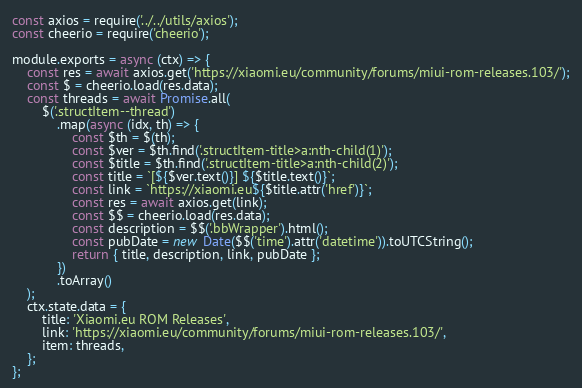<code> <loc_0><loc_0><loc_500><loc_500><_JavaScript_>const axios = require('../../utils/axios');
const cheerio = require('cheerio');

module.exports = async (ctx) => {
    const res = await axios.get('https://xiaomi.eu/community/forums/miui-rom-releases.103/');
    const $ = cheerio.load(res.data);
    const threads = await Promise.all(
        $('.structItem--thread')
            .map(async (idx, th) => {
                const $th = $(th);
                const $ver = $th.find('.structItem-title>a:nth-child(1)');
                const $title = $th.find('.structItem-title>a:nth-child(2)');
                const title = `[${$ver.text()}] ${$title.text()}`;
                const link = `https://xiaomi.eu${$title.attr('href')}`;
                const res = await axios.get(link);
                const $$ = cheerio.load(res.data);
                const description = $$('.bbWrapper').html();
                const pubDate = new Date($$('time').attr('datetime')).toUTCString();
                return { title, description, link, pubDate };
            })
            .toArray()
    );
    ctx.state.data = {
        title: 'Xiaomi.eu ROM Releases',
        link: 'https://xiaomi.eu/community/forums/miui-rom-releases.103/',
        item: threads,
    };
};
</code> 